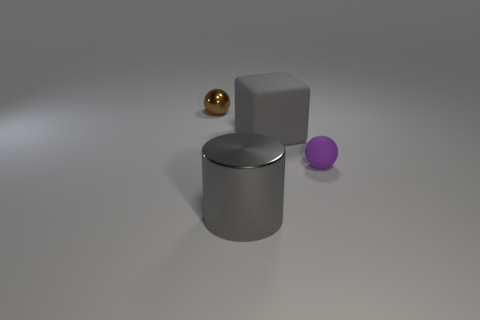Add 4 tiny objects. How many objects exist? 8 Subtract all blocks. How many objects are left? 3 Subtract 1 cubes. How many cubes are left? 0 Subtract all blue cubes. Subtract all yellow cylinders. How many cubes are left? 1 Subtract 1 purple balls. How many objects are left? 3 Subtract all red spheres. How many red blocks are left? 0 Subtract all large blocks. Subtract all small purple rubber things. How many objects are left? 2 Add 1 large metal things. How many large metal things are left? 2 Add 4 rubber cubes. How many rubber cubes exist? 5 